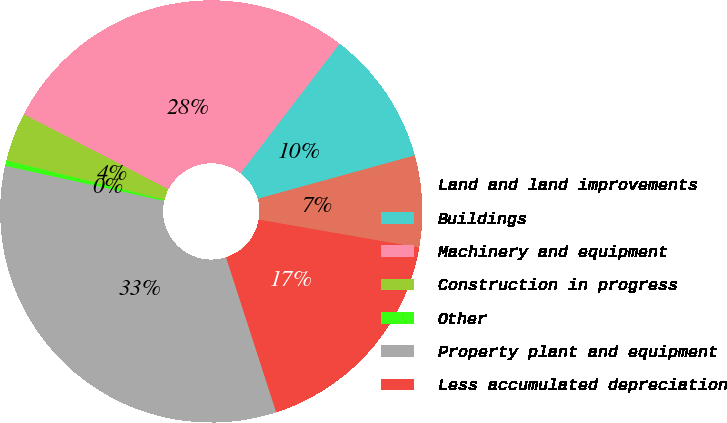Convert chart to OTSL. <chart><loc_0><loc_0><loc_500><loc_500><pie_chart><fcel>Land and land improvements<fcel>Buildings<fcel>Machinery and equipment<fcel>Construction in progress<fcel>Other<fcel>Property plant and equipment<fcel>Less accumulated depreciation<nl><fcel>7.03%<fcel>10.33%<fcel>27.78%<fcel>3.73%<fcel>0.42%<fcel>33.44%<fcel>17.27%<nl></chart> 